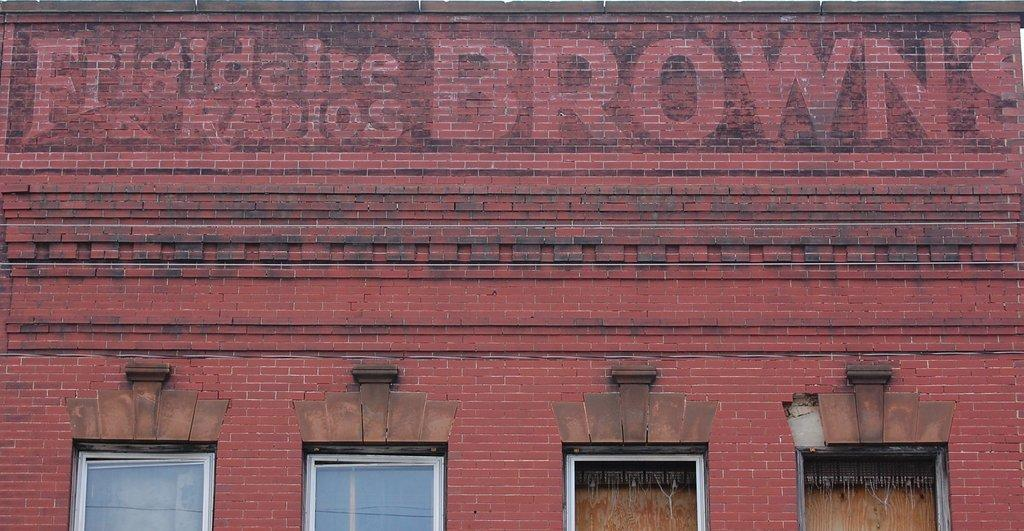What is located in the middle of the image? There is a building in the middle of the image. What specific features can be observed on the building? The building has windows. What objects can be seen inside the building? There are glasses visible inside the building. What can be found on the walls of the building? There is text visible on the walls of the building. Can you tell me how many spies are hiding behind the glasses in the building? There is no indication of spies or any hidden individuals in the image; it only shows a building with windows, glasses, and text on the walls. What type of lead is used to create the glasses in the building? There is no information about the material used to create the glasses in the image. 